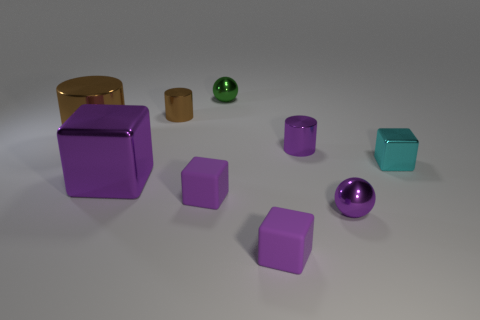Subtract all purple cubes. How many were subtracted if there are1purple cubes left? 2 Subtract all big metal blocks. How many blocks are left? 3 Subtract 2 cylinders. How many cylinders are left? 1 Subtract all brown blocks. Subtract all purple cylinders. How many blocks are left? 4 Subtract all cyan blocks. How many blocks are left? 3 Subtract all cyan cylinders. How many cyan cubes are left? 1 Subtract all tiny balls. Subtract all small cyan metallic cubes. How many objects are left? 6 Add 1 purple metal cylinders. How many purple metal cylinders are left? 2 Add 2 tiny matte cubes. How many tiny matte cubes exist? 4 Subtract 0 red cylinders. How many objects are left? 9 